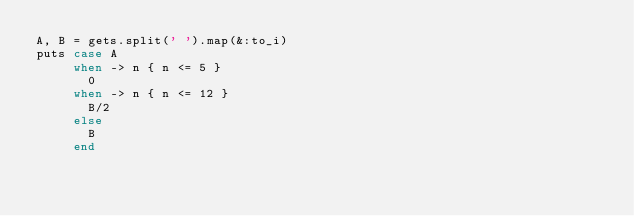<code> <loc_0><loc_0><loc_500><loc_500><_Ruby_>A, B = gets.split(' ').map(&:to_i)
puts case A
     when -> n { n <= 5 }
       0
     when -> n { n <= 12 }
       B/2
     else
       B
     end
  </code> 